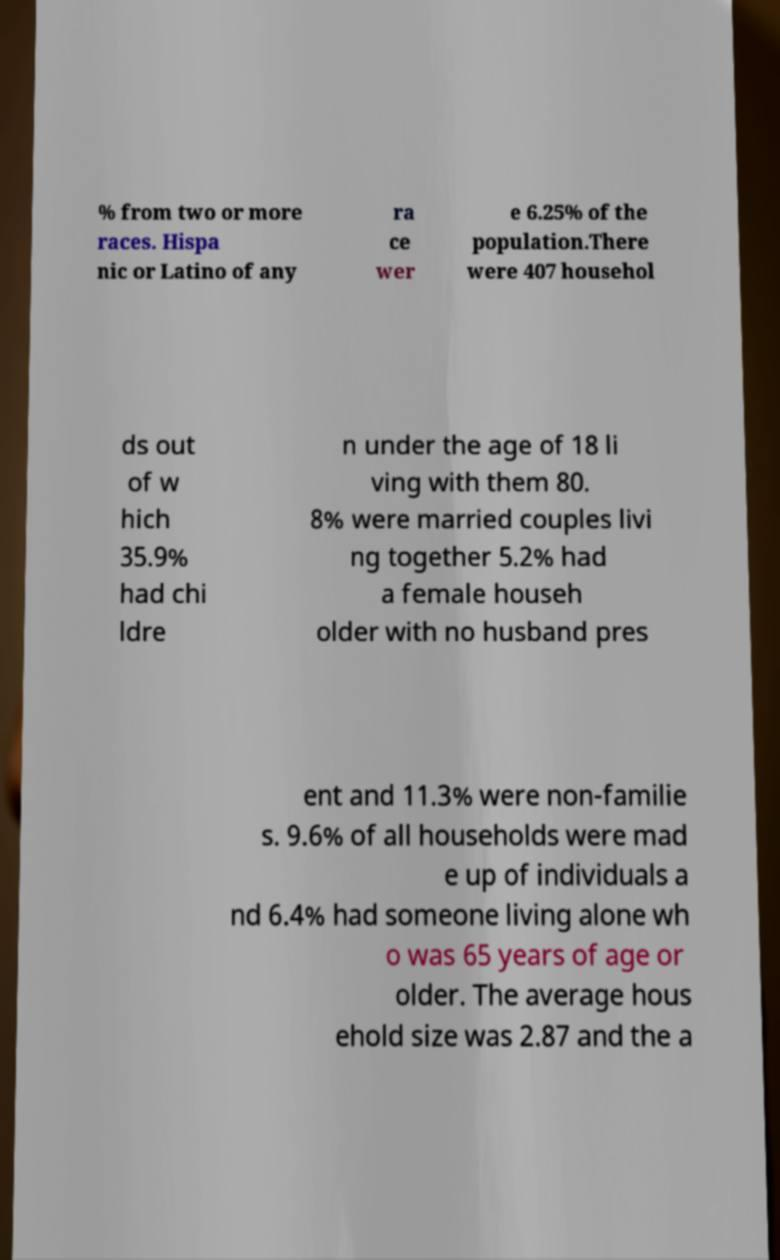Please identify and transcribe the text found in this image. % from two or more races. Hispa nic or Latino of any ra ce wer e 6.25% of the population.There were 407 househol ds out of w hich 35.9% had chi ldre n under the age of 18 li ving with them 80. 8% were married couples livi ng together 5.2% had a female househ older with no husband pres ent and 11.3% were non-familie s. 9.6% of all households were mad e up of individuals a nd 6.4% had someone living alone wh o was 65 years of age or older. The average hous ehold size was 2.87 and the a 